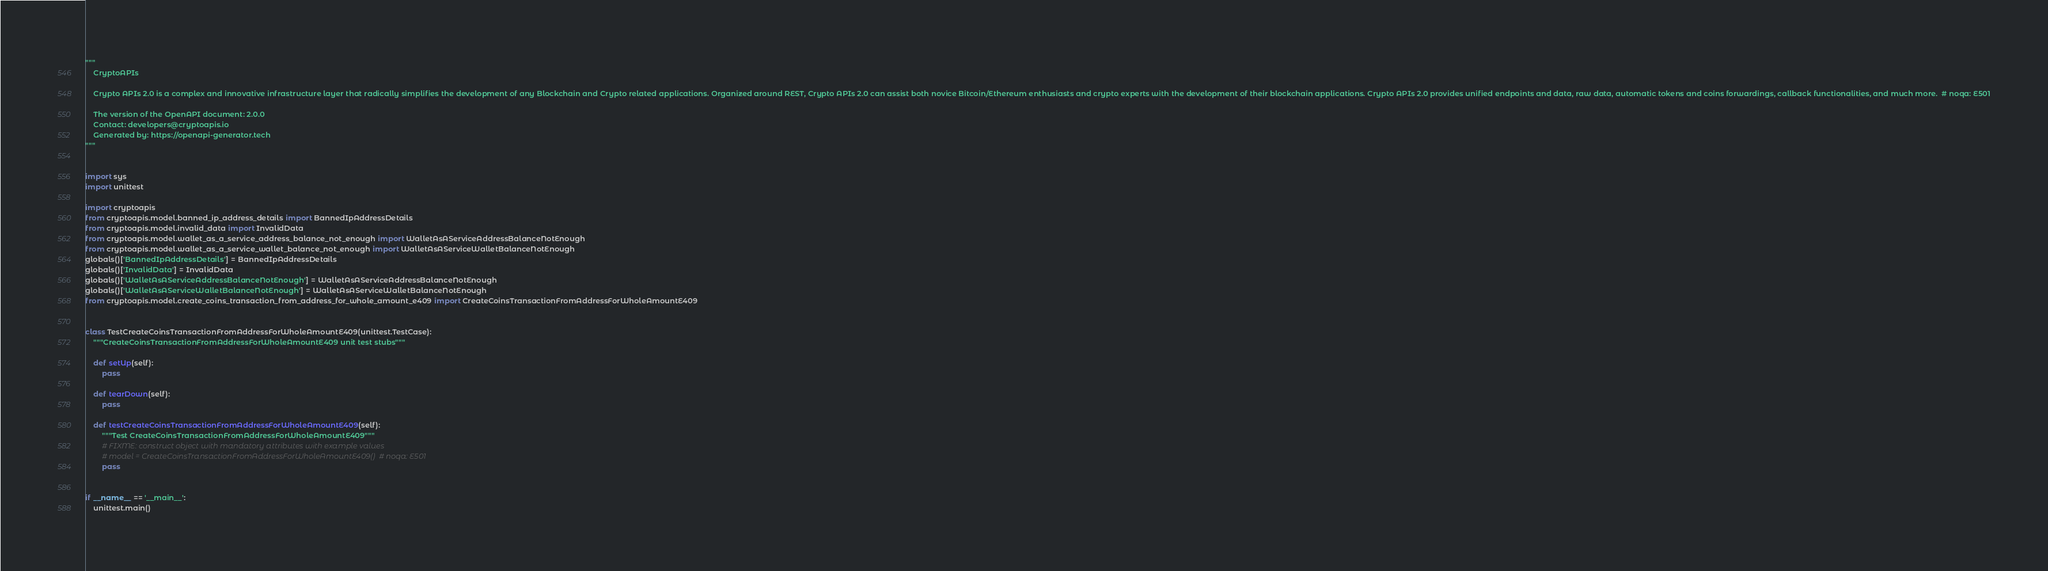<code> <loc_0><loc_0><loc_500><loc_500><_Python_>"""
    CryptoAPIs

    Crypto APIs 2.0 is a complex and innovative infrastructure layer that radically simplifies the development of any Blockchain and Crypto related applications. Organized around REST, Crypto APIs 2.0 can assist both novice Bitcoin/Ethereum enthusiasts and crypto experts with the development of their blockchain applications. Crypto APIs 2.0 provides unified endpoints and data, raw data, automatic tokens and coins forwardings, callback functionalities, and much more.  # noqa: E501

    The version of the OpenAPI document: 2.0.0
    Contact: developers@cryptoapis.io
    Generated by: https://openapi-generator.tech
"""


import sys
import unittest

import cryptoapis
from cryptoapis.model.banned_ip_address_details import BannedIpAddressDetails
from cryptoapis.model.invalid_data import InvalidData
from cryptoapis.model.wallet_as_a_service_address_balance_not_enough import WalletAsAServiceAddressBalanceNotEnough
from cryptoapis.model.wallet_as_a_service_wallet_balance_not_enough import WalletAsAServiceWalletBalanceNotEnough
globals()['BannedIpAddressDetails'] = BannedIpAddressDetails
globals()['InvalidData'] = InvalidData
globals()['WalletAsAServiceAddressBalanceNotEnough'] = WalletAsAServiceAddressBalanceNotEnough
globals()['WalletAsAServiceWalletBalanceNotEnough'] = WalletAsAServiceWalletBalanceNotEnough
from cryptoapis.model.create_coins_transaction_from_address_for_whole_amount_e409 import CreateCoinsTransactionFromAddressForWholeAmountE409


class TestCreateCoinsTransactionFromAddressForWholeAmountE409(unittest.TestCase):
    """CreateCoinsTransactionFromAddressForWholeAmountE409 unit test stubs"""

    def setUp(self):
        pass

    def tearDown(self):
        pass

    def testCreateCoinsTransactionFromAddressForWholeAmountE409(self):
        """Test CreateCoinsTransactionFromAddressForWholeAmountE409"""
        # FIXME: construct object with mandatory attributes with example values
        # model = CreateCoinsTransactionFromAddressForWholeAmountE409()  # noqa: E501
        pass


if __name__ == '__main__':
    unittest.main()
</code> 